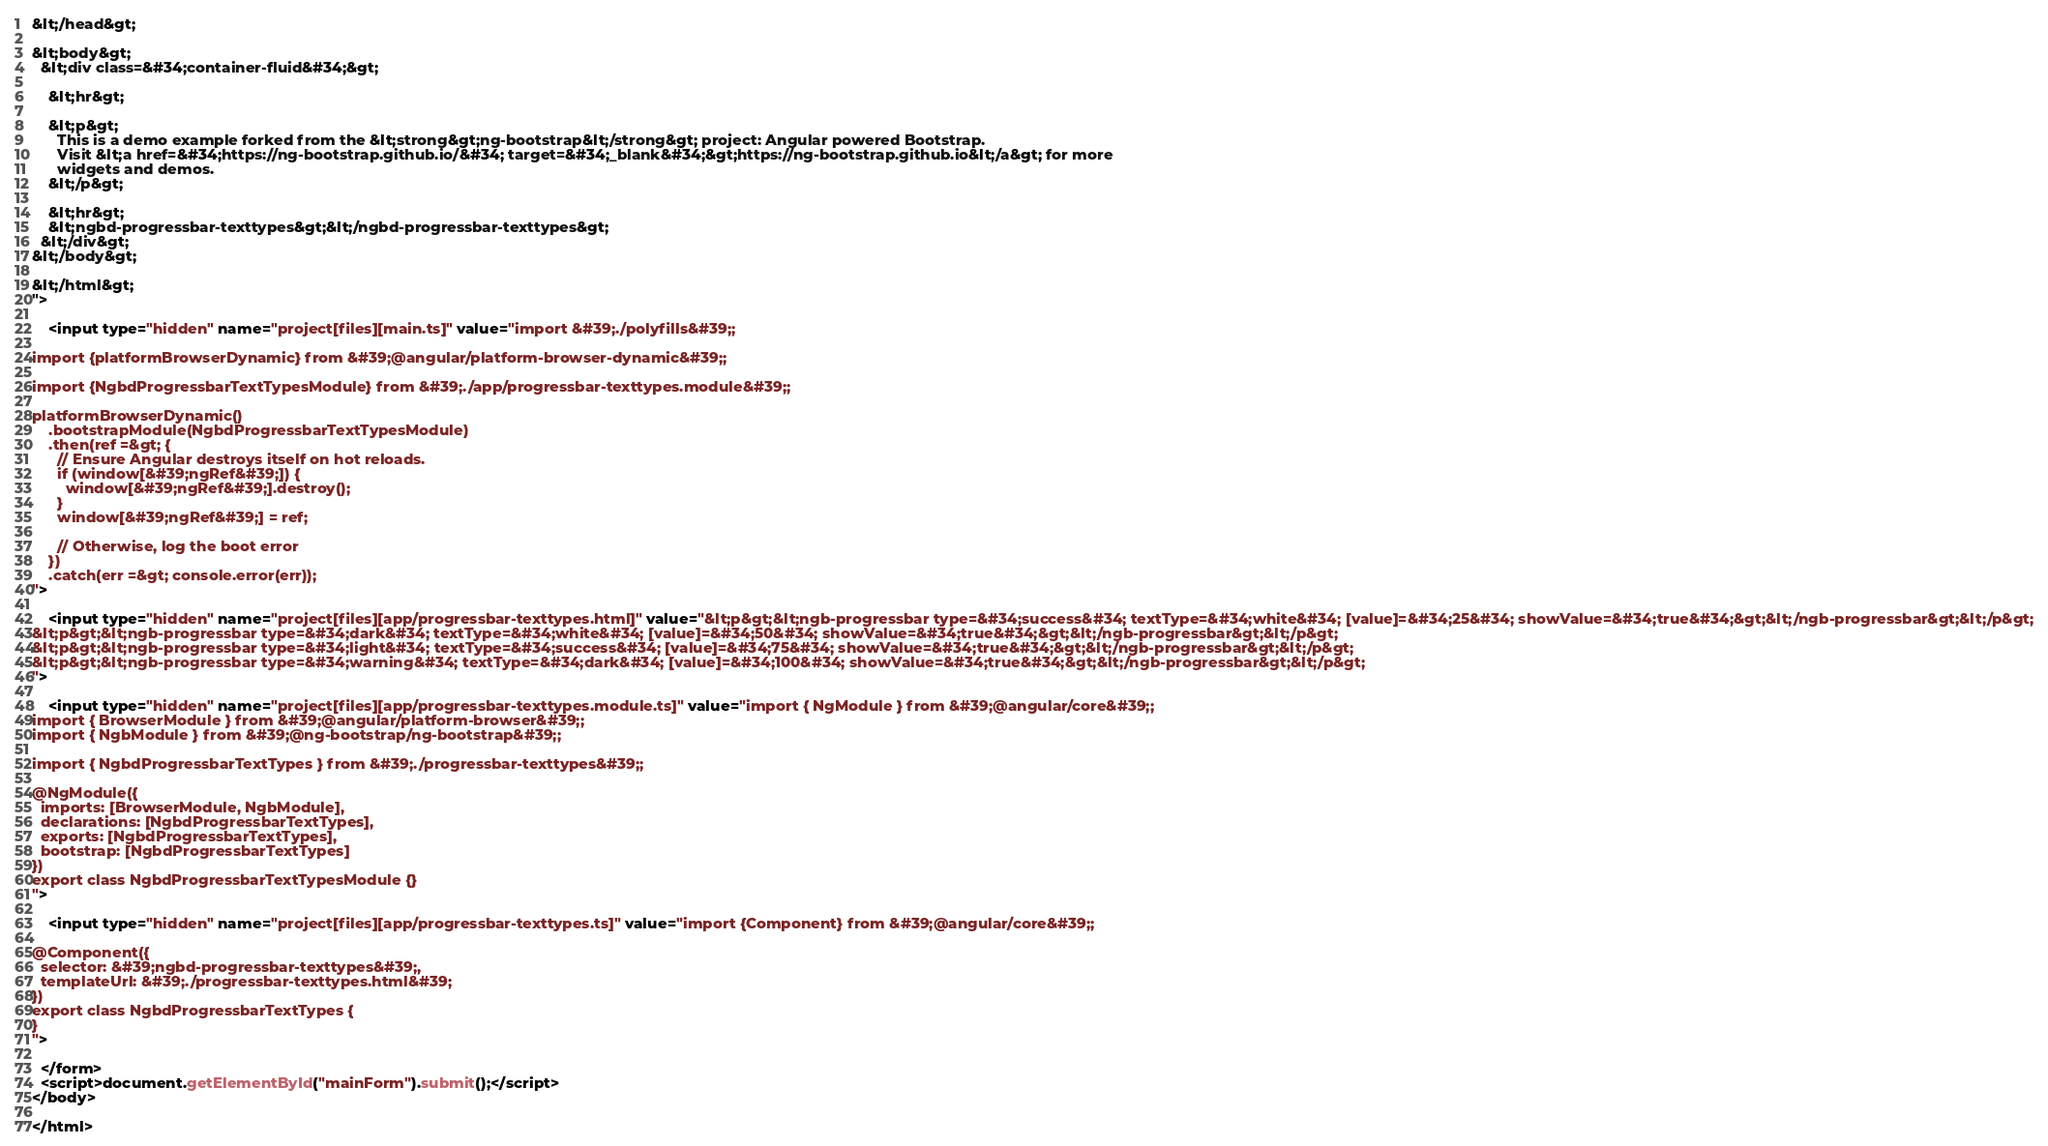Convert code to text. <code><loc_0><loc_0><loc_500><loc_500><_HTML_>&lt;/head&gt;

&lt;body&gt;
  &lt;div class=&#34;container-fluid&#34;&gt;

    &lt;hr&gt;

    &lt;p&gt;
      This is a demo example forked from the &lt;strong&gt;ng-bootstrap&lt;/strong&gt; project: Angular powered Bootstrap.
      Visit &lt;a href=&#34;https://ng-bootstrap.github.io/&#34; target=&#34;_blank&#34;&gt;https://ng-bootstrap.github.io&lt;/a&gt; for more
      widgets and demos.
    &lt;/p&gt;

    &lt;hr&gt;
    &lt;ngbd-progressbar-texttypes&gt;&lt;/ngbd-progressbar-texttypes&gt;
  &lt;/div&gt;
&lt;/body&gt;

&lt;/html&gt;
">
    
    <input type="hidden" name="project[files][main.ts]" value="import &#39;./polyfills&#39;;

import {platformBrowserDynamic} from &#39;@angular/platform-browser-dynamic&#39;;

import {NgbdProgressbarTextTypesModule} from &#39;./app/progressbar-texttypes.module&#39;;

platformBrowserDynamic()
    .bootstrapModule(NgbdProgressbarTextTypesModule)
    .then(ref =&gt; {
      // Ensure Angular destroys itself on hot reloads.
      if (window[&#39;ngRef&#39;]) {
        window[&#39;ngRef&#39;].destroy();
      }
      window[&#39;ngRef&#39;] = ref;

      // Otherwise, log the boot error
    })
    .catch(err =&gt; console.error(err));
">
    
    <input type="hidden" name="project[files][app/progressbar-texttypes.html]" value="&lt;p&gt;&lt;ngb-progressbar type=&#34;success&#34; textType=&#34;white&#34; [value]=&#34;25&#34; showValue=&#34;true&#34;&gt;&lt;/ngb-progressbar&gt;&lt;/p&gt;
&lt;p&gt;&lt;ngb-progressbar type=&#34;dark&#34; textType=&#34;white&#34; [value]=&#34;50&#34; showValue=&#34;true&#34;&gt;&lt;/ngb-progressbar&gt;&lt;/p&gt;
&lt;p&gt;&lt;ngb-progressbar type=&#34;light&#34; textType=&#34;success&#34; [value]=&#34;75&#34; showValue=&#34;true&#34;&gt;&lt;/ngb-progressbar&gt;&lt;/p&gt;
&lt;p&gt;&lt;ngb-progressbar type=&#34;warning&#34; textType=&#34;dark&#34; [value]=&#34;100&#34; showValue=&#34;true&#34;&gt;&lt;/ngb-progressbar&gt;&lt;/p&gt;
">
    
    <input type="hidden" name="project[files][app/progressbar-texttypes.module.ts]" value="import { NgModule } from &#39;@angular/core&#39;;
import { BrowserModule } from &#39;@angular/platform-browser&#39;;
import { NgbModule } from &#39;@ng-bootstrap/ng-bootstrap&#39;;

import { NgbdProgressbarTextTypes } from &#39;./progressbar-texttypes&#39;;

@NgModule({
  imports: [BrowserModule, NgbModule],
  declarations: [NgbdProgressbarTextTypes],
  exports: [NgbdProgressbarTextTypes],
  bootstrap: [NgbdProgressbarTextTypes]
})
export class NgbdProgressbarTextTypesModule {}
">
    
    <input type="hidden" name="project[files][app/progressbar-texttypes.ts]" value="import {Component} from &#39;@angular/core&#39;;

@Component({
  selector: &#39;ngbd-progressbar-texttypes&#39;,
  templateUrl: &#39;./progressbar-texttypes.html&#39;
})
export class NgbdProgressbarTextTypes {
}
">
    
  </form>
  <script>document.getElementById("mainForm").submit();</script>
</body>

</html>
</code> 